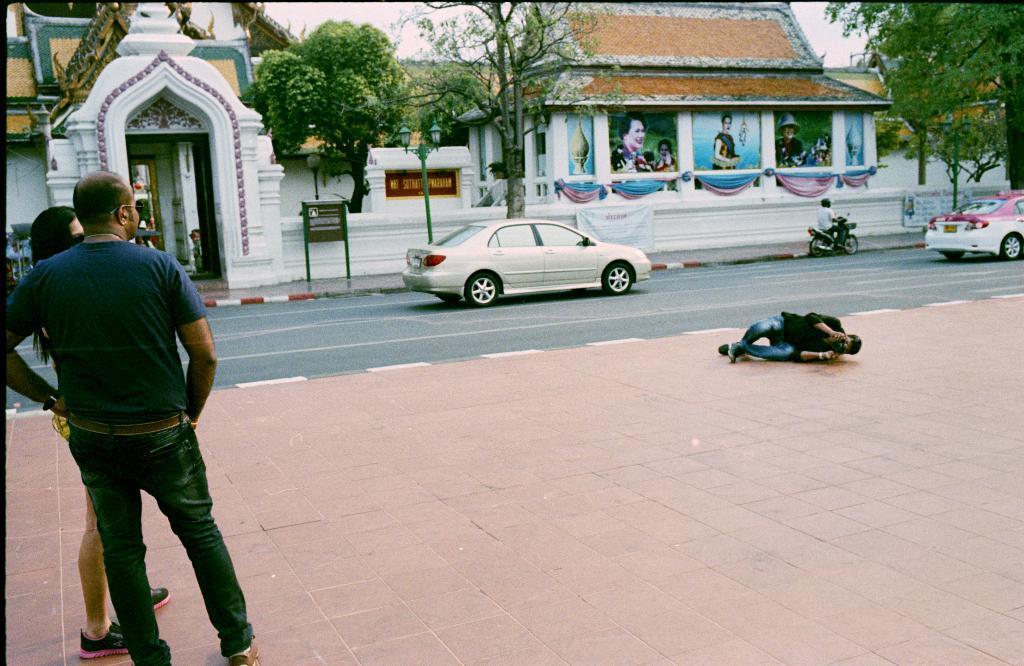In one or two sentences, can you explain what this image depicts? In this image there is a person lying on the pavement. He is holding a camera. Left side there is a woman standing. Beside her there is a person. There are vehicles on the road. A person is riding the bike. There is a board attached to the poles. Background there are trees and buildings. Top of the image there is sky. 